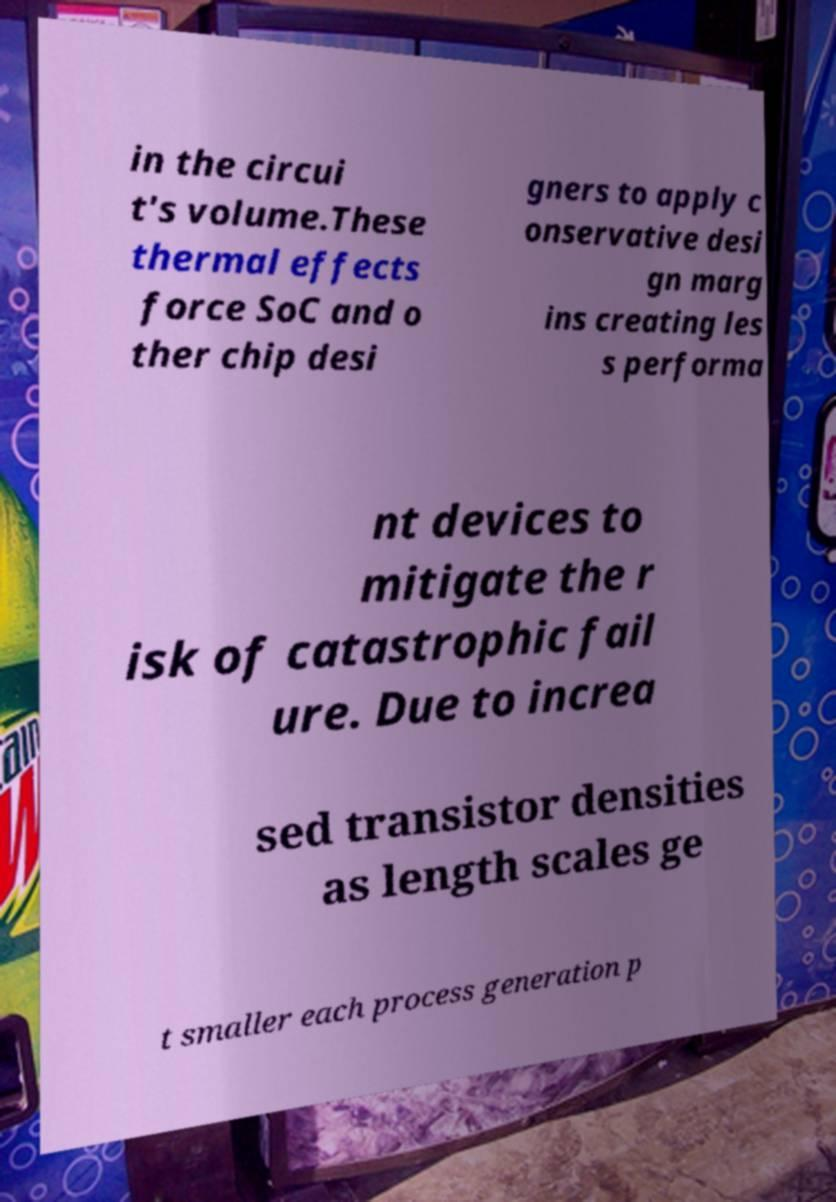Please identify and transcribe the text found in this image. in the circui t's volume.These thermal effects force SoC and o ther chip desi gners to apply c onservative desi gn marg ins creating les s performa nt devices to mitigate the r isk of catastrophic fail ure. Due to increa sed transistor densities as length scales ge t smaller each process generation p 